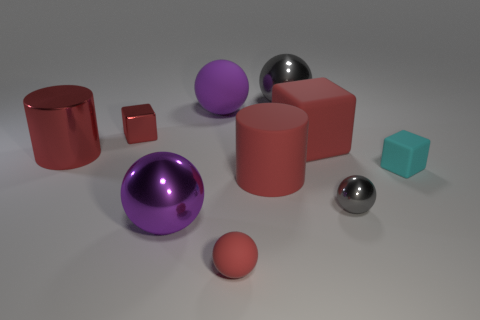Subtract all tiny metal blocks. How many blocks are left? 2 Subtract 4 spheres. How many spheres are left? 1 Subtract all gray spheres. How many spheres are left? 3 Subtract all cylinders. How many objects are left? 8 Add 6 big red metal cylinders. How many big red metal cylinders exist? 7 Subtract 0 cyan balls. How many objects are left? 10 Subtract all yellow spheres. Subtract all brown cylinders. How many spheres are left? 5 Subtract all brown cylinders. How many cyan cubes are left? 1 Subtract all green matte things. Subtract all small matte objects. How many objects are left? 8 Add 4 purple balls. How many purple balls are left? 6 